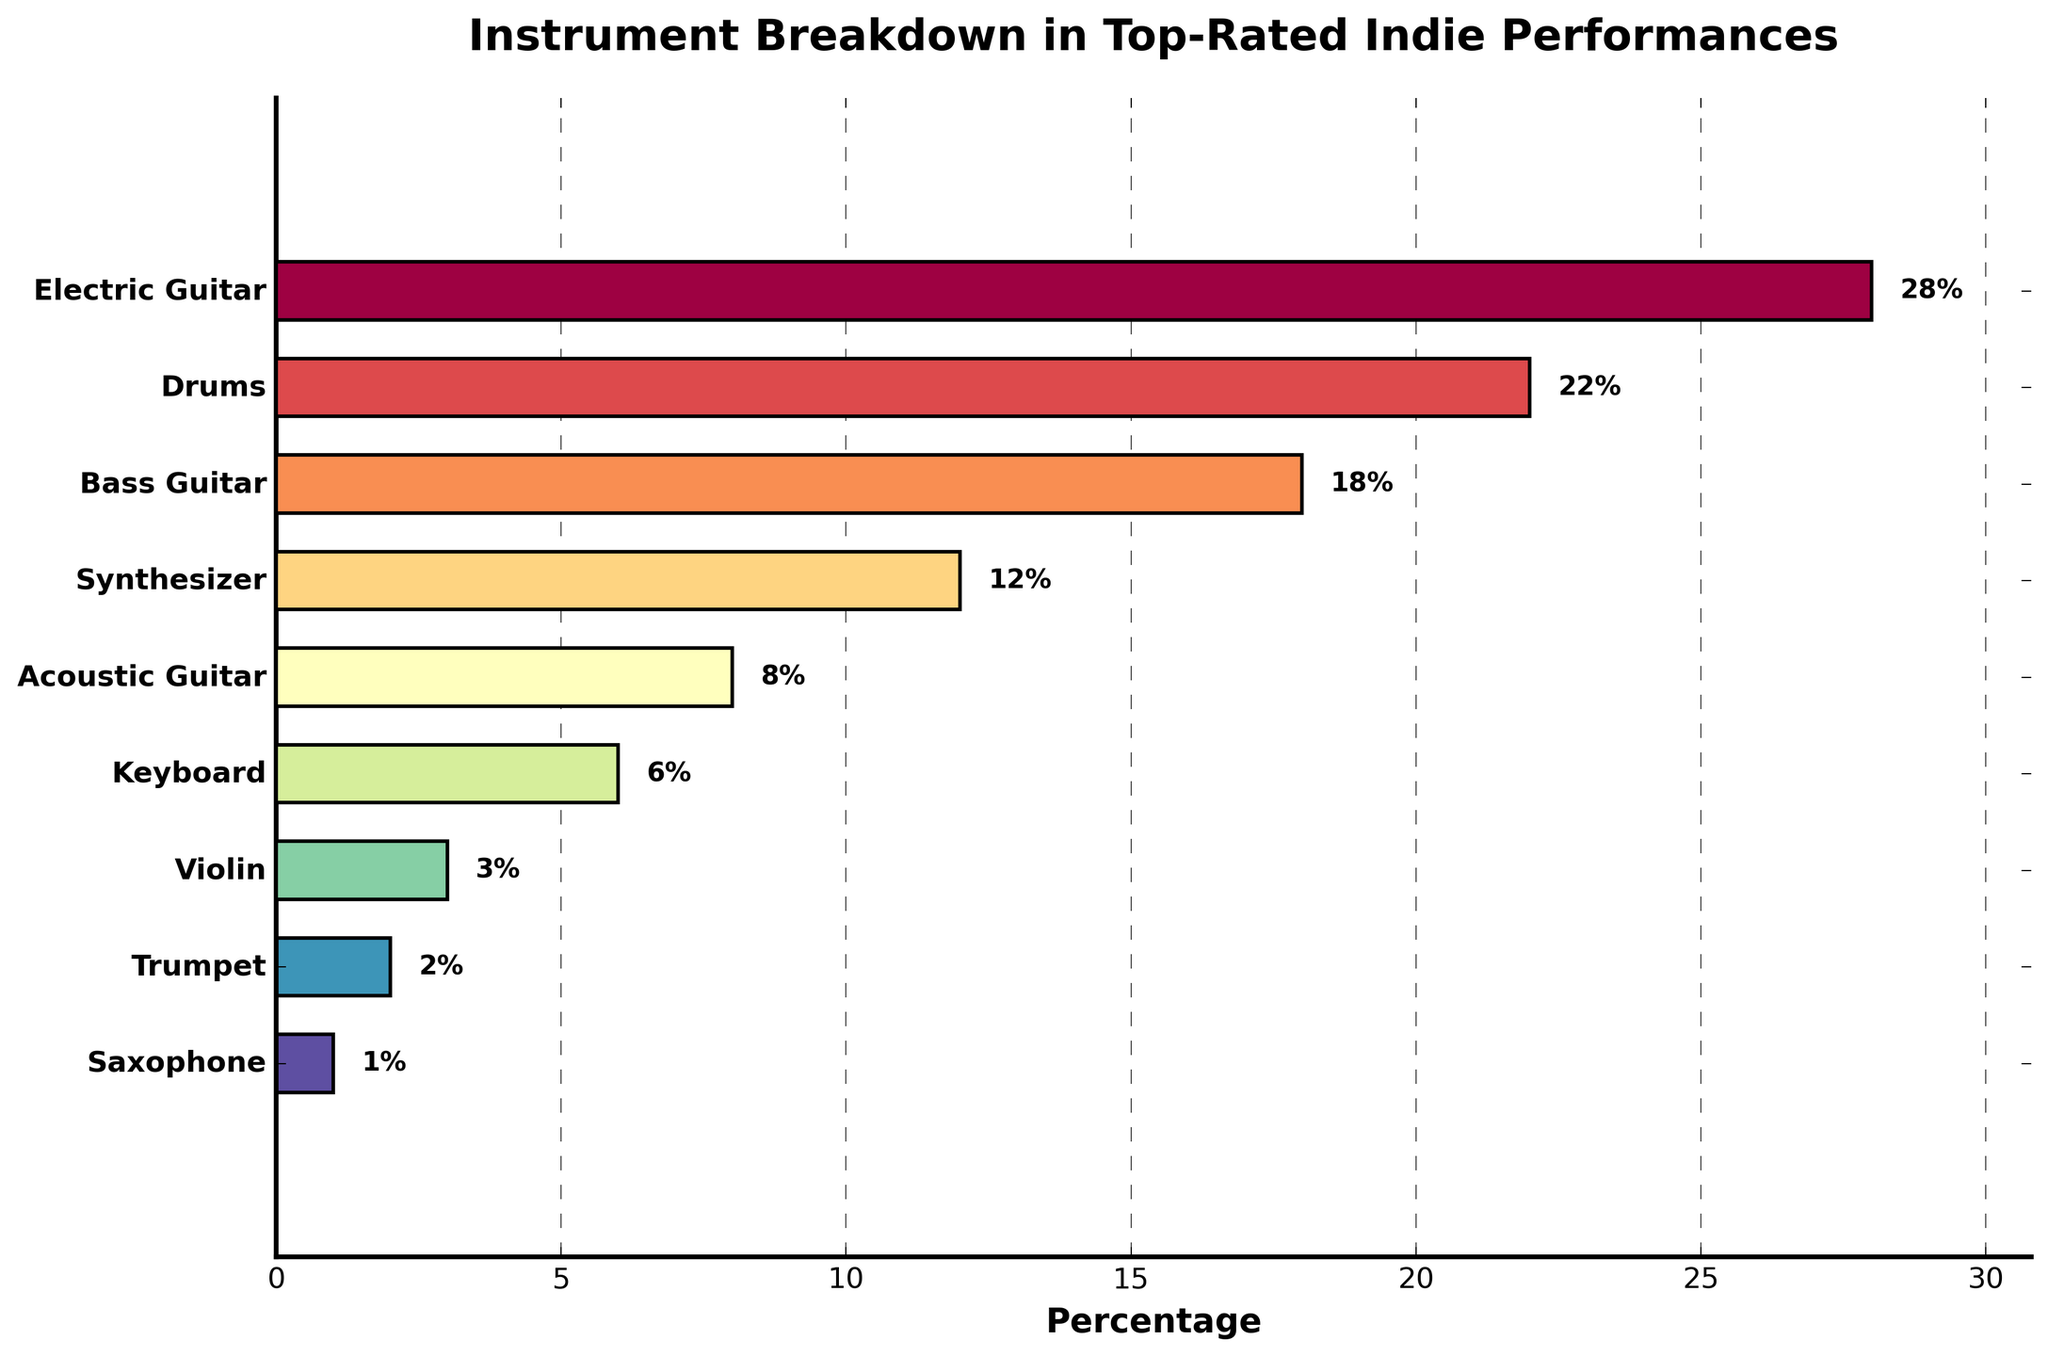Which instrument has the highest percentage in top-rated indie band performances? The instrument with the highest percentage is the one represented by the tallest bar on the horizontal bar chart. In this case, the Electric Guitar has the tallest bar.
Answer: Electric Guitar What is the total percentage of Electric Guitar and Drums usage combined? To find the total percentage, sum the individual percentages of Electric Guitar and Drums. Electric Guitar is 28% and Drums is 22%, so 28 + 22 = 50%.
Answer: 50% Which instrument is used less than 5% of the time? The instruments with percentages less than 5% are the ones with shorter bars towards the bottom of the chart. In this case, the Violin, Trumpet, and Saxophone are used 3%, 2%, and 1% of the time, respectively.
Answer: (Any of: Violin, Trumpet, Saxophone) How many instruments are used in more than 10% of the performances? Count the number of bars that have percentages higher than 10%. The Electric Guitar (28%), Drums (22%), Bass Guitar (18%), and Synthesizer (12%) all exceed 10%.
Answer: 4 What is the difference in percentage between the most used instrument and the least used instrument? Subtract the percentage of the least used instrument (Saxophone, 1%) from the percentage of the most used instrument (Electric Guitar, 28%). So, 28 - 1 = 27%.
Answer: 27% Are there more instruments used within 5-10% or within 10-20% of the performances? Count the number of bars that fall within the 5-10% range and those that fall within the 10-20% range. Within 5-10%, there are Acoustic Guitar (8%) and Keyboard (6%) – 2 instruments. Within 10-20%, there are Bass Guitar (18%) and Synthesizer (12%) – 2 instruments. Both ranges have the same number of bars.
Answer: Equal (2 for each range) What is the median percentage use of the instruments? To find the median, list all percentages in order: 1%, 2%, 3%, 6%, 8%, 12%, 18%, 22%, 28%. The middle value is the 5th number, which is 8%.
Answer: 8% Which instrument's usage is exactly half of the most used instrument's percentage? Find half of the Electric Guitar percentage (28%), which is 14%. Then look for an instrument with a percentage close to or exactly 14%. There isn’t an instrument with exactly 14%, but Synthesizer is quite near at 12%.
Answer: None exactly; Synthesizer is closest How many instruments are used the same percentage as or less frequently than Keyboard? Count all instruments with percentages equal to or less than 6%. Those instruments are Keyboard (6%), Violin (3%), Trumpet (2%), Saxophone (1%).
Answer: 4 If you were to combine the percentages of Acoustic Guitar and Keyboard, would it exceed the usage of Bass Guitar? Sum the percentages of Acoustic Guitar (8%) and Keyboard (6%) and compare it to Bass Guitar (18%). 8 + 6 = 14% < 18%, so it would not exceed it.
Answer: No 